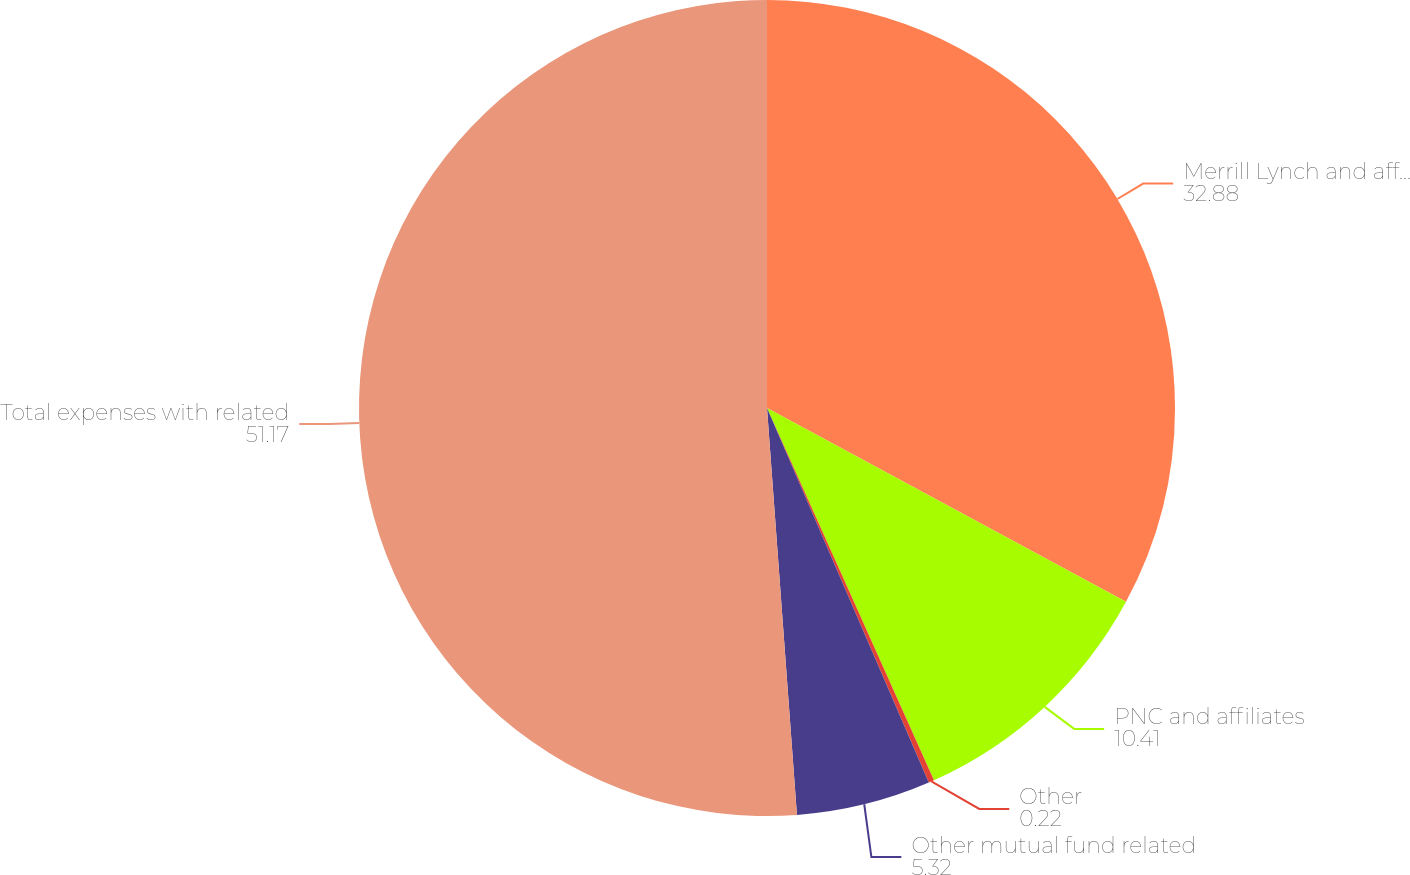<chart> <loc_0><loc_0><loc_500><loc_500><pie_chart><fcel>Merrill Lynch and affiliates<fcel>PNC and affiliates<fcel>Other<fcel>Other mutual fund related<fcel>Total expenses with related<nl><fcel>32.88%<fcel>10.41%<fcel>0.22%<fcel>5.32%<fcel>51.17%<nl></chart> 